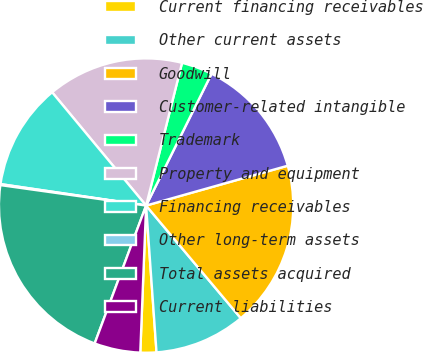Convert chart. <chart><loc_0><loc_0><loc_500><loc_500><pie_chart><fcel>Current financing receivables<fcel>Other current assets<fcel>Goodwill<fcel>Customer-related intangible<fcel>Trademark<fcel>Property and equipment<fcel>Financing receivables<fcel>Other long-term assets<fcel>Total assets acquired<fcel>Current liabilities<nl><fcel>1.76%<fcel>10.0%<fcel>18.24%<fcel>13.3%<fcel>3.41%<fcel>14.95%<fcel>11.65%<fcel>0.11%<fcel>21.54%<fcel>5.05%<nl></chart> 